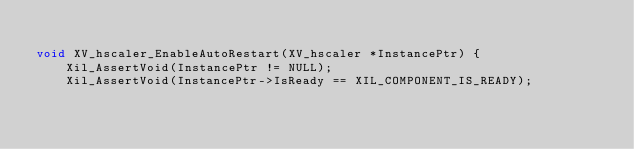<code> <loc_0><loc_0><loc_500><loc_500><_C_>
void XV_hscaler_EnableAutoRestart(XV_hscaler *InstancePtr) {
    Xil_AssertVoid(InstancePtr != NULL);
    Xil_AssertVoid(InstancePtr->IsReady == XIL_COMPONENT_IS_READY);
</code> 